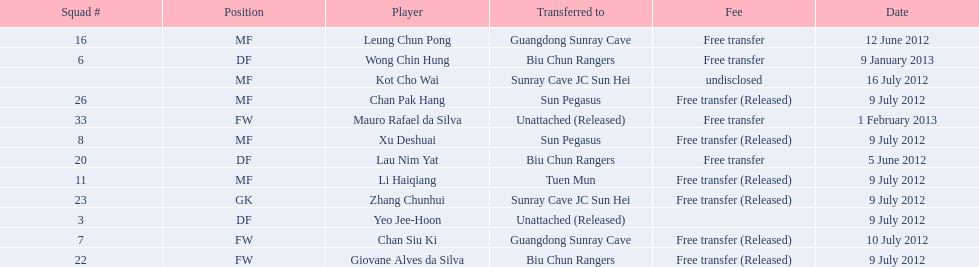Which players are listed? Lau Nim Yat, Leung Chun Pong, Yeo Jee-Hoon, Xu Deshuai, Li Haiqiang, Giovane Alves da Silva, Zhang Chunhui, Chan Pak Hang, Chan Siu Ki, Kot Cho Wai, Wong Chin Hung, Mauro Rafael da Silva. Which dates were players transferred to the biu chun rangers? 5 June 2012, 9 July 2012, 9 January 2013. Of those which is the date for wong chin hung? 9 January 2013. 